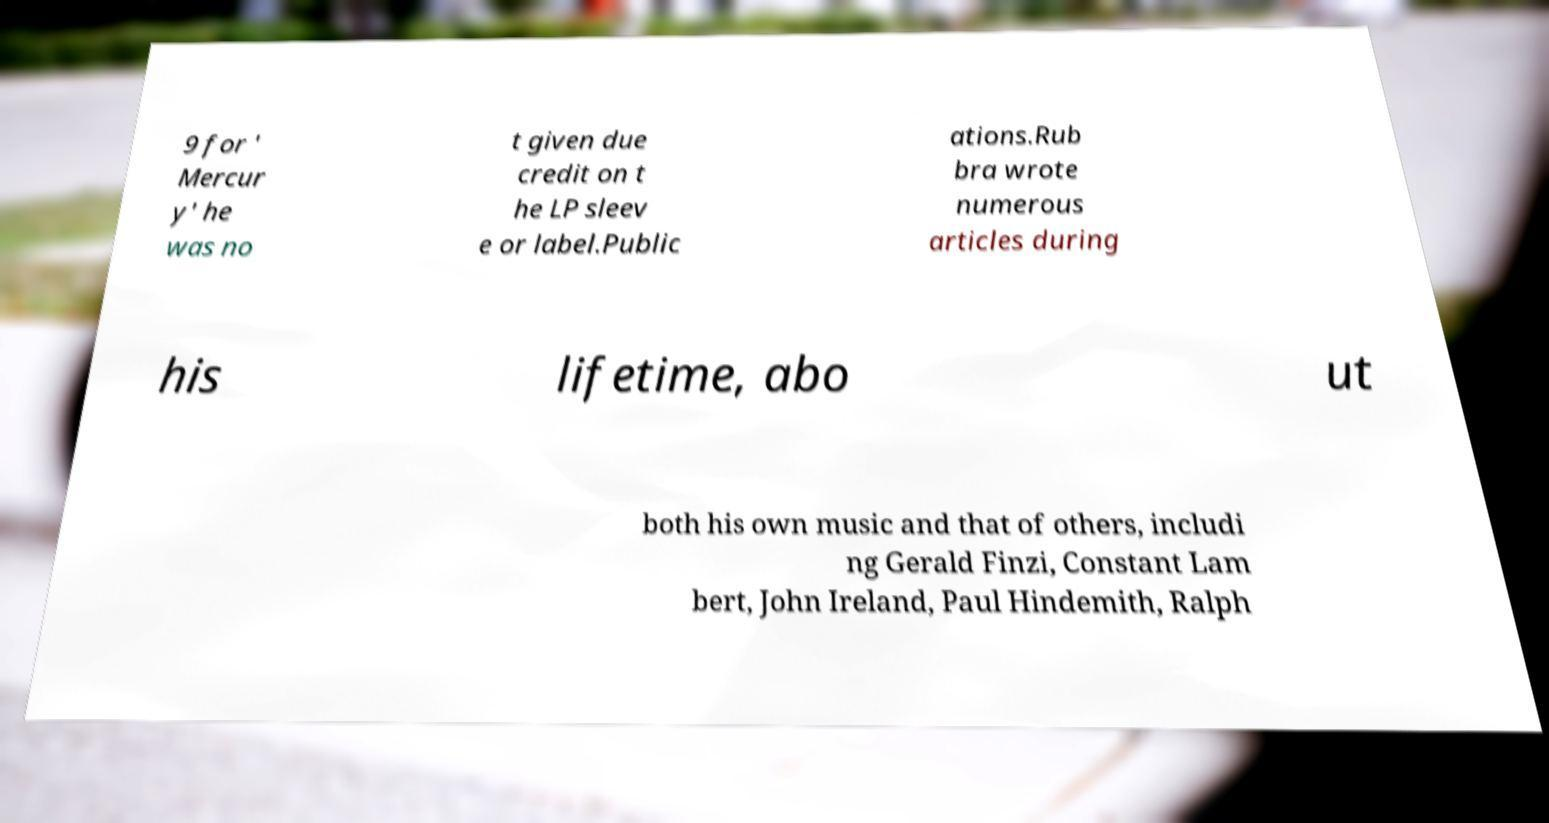Could you extract and type out the text from this image? 9 for ' Mercur y' he was no t given due credit on t he LP sleev e or label.Public ations.Rub bra wrote numerous articles during his lifetime, abo ut both his own music and that of others, includi ng Gerald Finzi, Constant Lam bert, John Ireland, Paul Hindemith, Ralph 